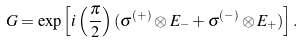Convert formula to latex. <formula><loc_0><loc_0><loc_500><loc_500>G = \exp \left [ i \left ( \frac { \pi } { 2 } \right ) ( \sigma ^ { ( + ) } \otimes E _ { - } + \sigma ^ { ( - ) } \otimes E _ { + } ) \right ] .</formula> 